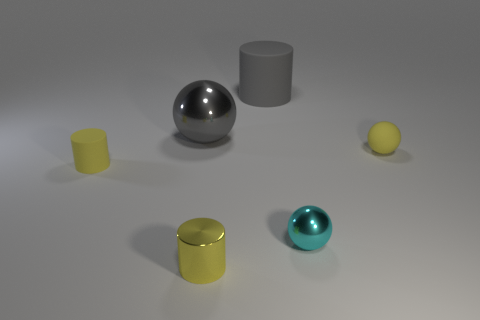How many other small metal things have the same shape as the gray metallic thing?
Provide a succinct answer. 1. What material is the cylinder behind the small rubber ball?
Provide a short and direct response. Rubber. Is the shape of the small metal object that is in front of the small metallic sphere the same as  the gray rubber object?
Your answer should be very brief. Yes. Is there a yellow shiny cylinder of the same size as the yellow rubber sphere?
Ensure brevity in your answer.  Yes. There is a gray rubber thing; does it have the same shape as the matte thing that is to the left of the gray metal ball?
Make the answer very short. Yes. There is a small metallic thing that is the same color as the tiny matte ball; what is its shape?
Provide a short and direct response. Cylinder. Are there fewer gray cylinders right of the small yellow metallic cylinder than cyan rubber cylinders?
Make the answer very short. No. Is the shape of the yellow metal thing the same as the gray metallic thing?
Offer a very short reply. No. What size is the cylinder that is the same material as the gray sphere?
Your answer should be compact. Small. Are there fewer things than tiny spheres?
Your response must be concise. No. 